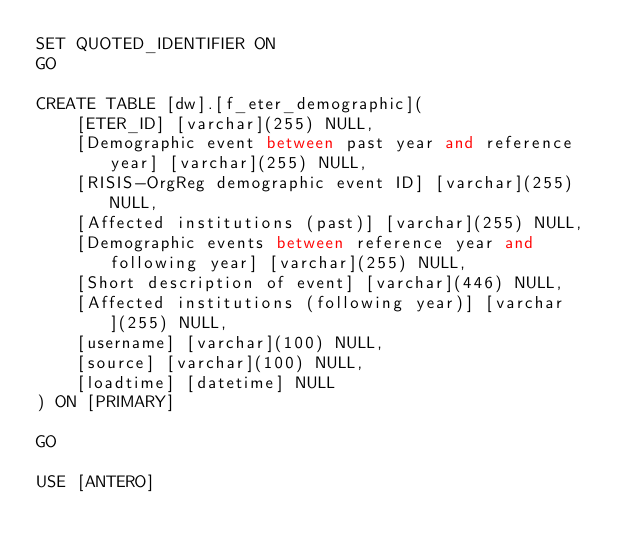<code> <loc_0><loc_0><loc_500><loc_500><_SQL_>SET QUOTED_IDENTIFIER ON
GO

CREATE TABLE [dw].[f_eter_demographic](
	[ETER_ID] [varchar](255) NULL,
	[Demographic event between past year and reference year] [varchar](255) NULL,
	[RISIS-OrgReg demographic event ID] [varchar](255) NULL,
	[Affected institutions (past)] [varchar](255) NULL,
	[Demographic events between reference year and following year] [varchar](255) NULL,
	[Short description of event] [varchar](446) NULL,
	[Affected institutions (following year)] [varchar](255) NULL,
	[username] [varchar](100) NULL,
	[source] [varchar](100) NULL,
	[loadtime] [datetime] NULL
) ON [PRIMARY]

GO

USE [ANTERO]</code> 